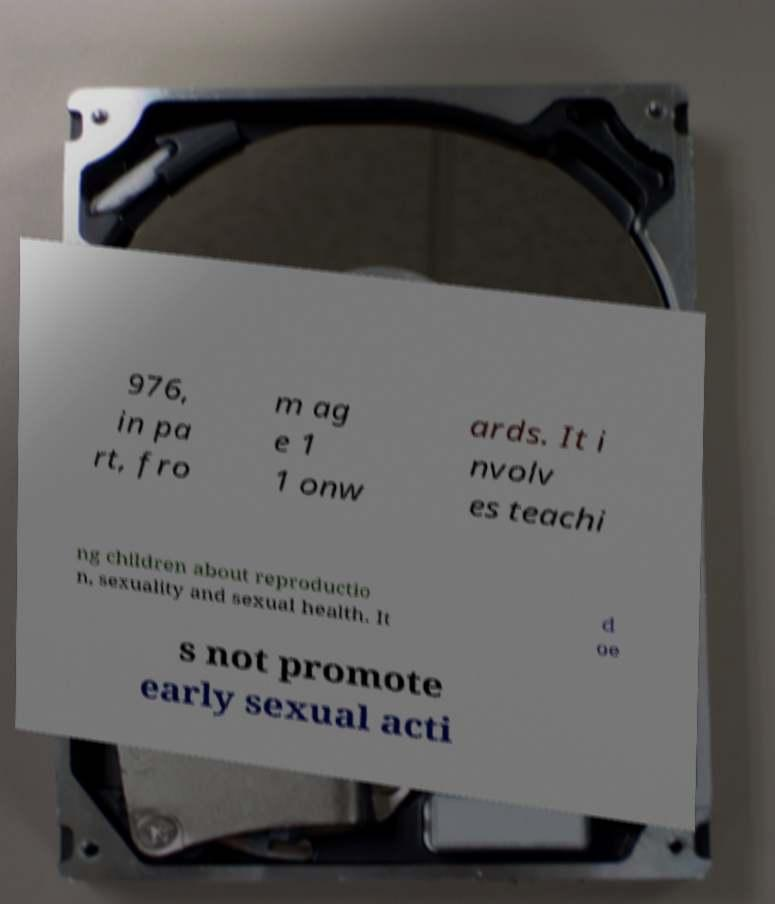Please identify and transcribe the text found in this image. 976, in pa rt, fro m ag e 1 1 onw ards. It i nvolv es teachi ng children about reproductio n, sexuality and sexual health. It d oe s not promote early sexual acti 